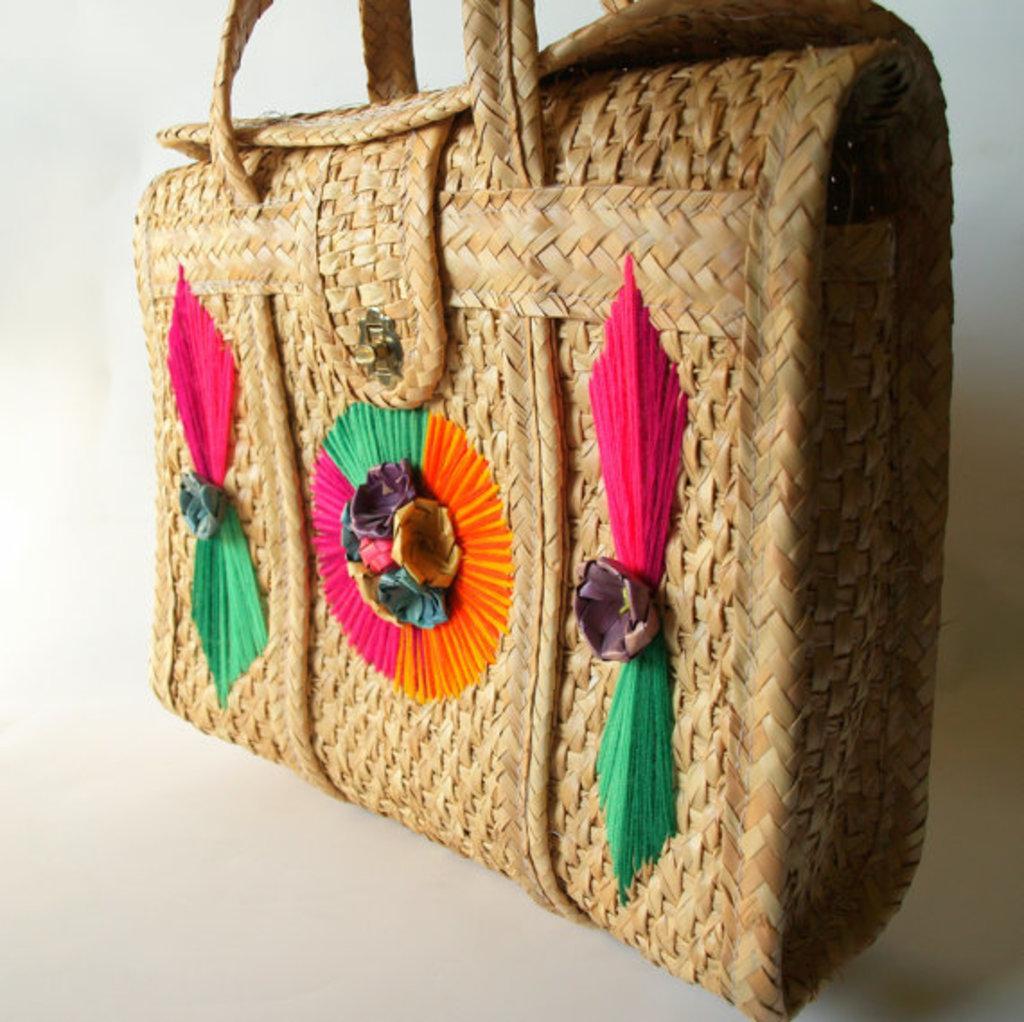Describe this image in one or two sentences. It is handmade bag. 